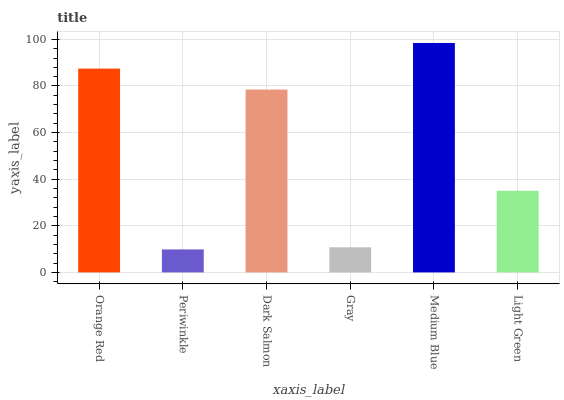Is Periwinkle the minimum?
Answer yes or no. Yes. Is Medium Blue the maximum?
Answer yes or no. Yes. Is Dark Salmon the minimum?
Answer yes or no. No. Is Dark Salmon the maximum?
Answer yes or no. No. Is Dark Salmon greater than Periwinkle?
Answer yes or no. Yes. Is Periwinkle less than Dark Salmon?
Answer yes or no. Yes. Is Periwinkle greater than Dark Salmon?
Answer yes or no. No. Is Dark Salmon less than Periwinkle?
Answer yes or no. No. Is Dark Salmon the high median?
Answer yes or no. Yes. Is Light Green the low median?
Answer yes or no. Yes. Is Light Green the high median?
Answer yes or no. No. Is Dark Salmon the low median?
Answer yes or no. No. 